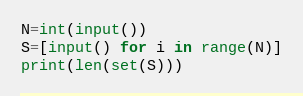<code> <loc_0><loc_0><loc_500><loc_500><_Python_>N=int(input())
S=[input() for i in range(N)]
print(len(set(S)))</code> 